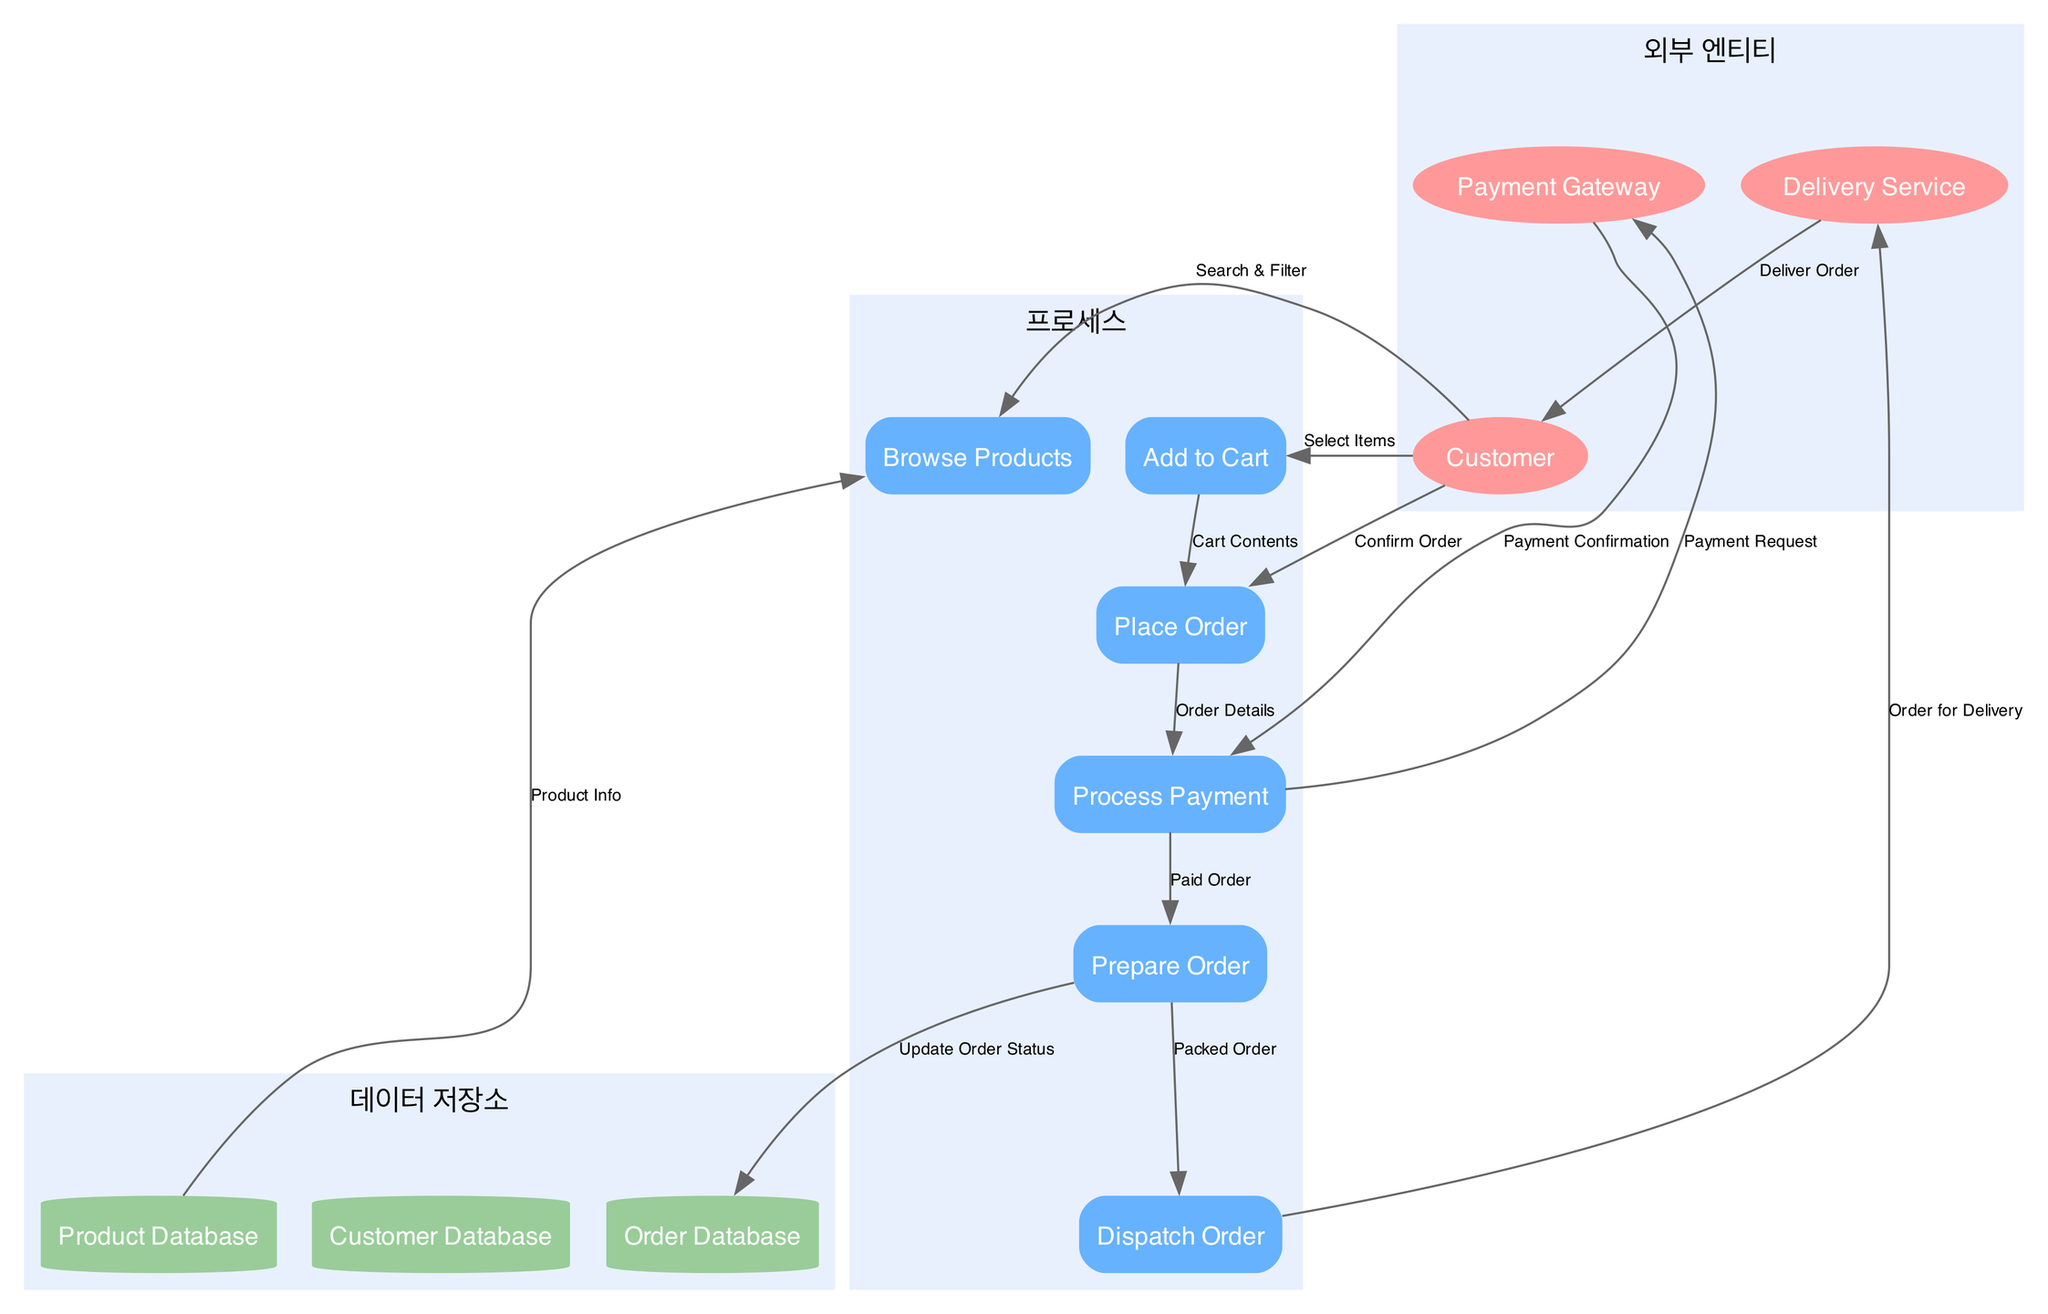What are the external entities in the diagram? The diagram defines three external entities: Customer, Payment Gateway, and Delivery Service. This is shown in the section labeled "외부 엔티티," where each entity is represented as an ellipse.
Answer: Customer, Payment Gateway, Delivery Service How many processes are represented in the diagram? The diagram has a total of six processes, including Browse Products, Add to Cart, Place Order, Process Payment, Prepare Order, and Dispatch Order. This is evident from the section labeled "프로세스."
Answer: 6 What is the data flow from the Customer to the Place Order process? The Customer sends the Confirm Order data flow to the Place Order process. Additionally, the flow is represented within the diagram by an arrow indicating the connection between these two nodes.
Answer: Confirm Order Which data store is updated after the Prepare Order process? After the Prepare Order process, the Order Database is updated with the order status, as indicated by the data flow labeled "Update Order Status." This shows the interaction between the Prepare Order process and the Order Database.
Answer: Order Database What is the sequence of interactions from placing the order to processing the payment? The sequence involves the Place Order process receiving order details from the Customer, then sending this to the Process Payment process which subsequently interacts with the Payment Gateway for payment confirmation. This flow involves three steps: Confirm Order, Order Details, and Payment Request.
Answer: Place Order to Process Payment How many data stores are present in the diagram? There are three data stores, which are Product Database, Customer Database, and Order Database. This is specified in the section labeled "데이터 저장소."
Answer: 3 What does the Delivery Service receive to complete its task? The Delivery Service receives the data flow labeled "Order for Delivery" from the Dispatch Order process. This indicates what information is handed over to the Delivery Service to execute the delivery.
Answer: Order for Delivery What is the first step the Customer takes in the online grocery shopping process? The first step taken by the Customer is to Browse Products, indicated by the initial connection in the flow where the Customer searches for and filters items.
Answer: Browse Products 